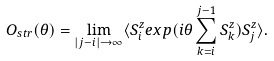<formula> <loc_0><loc_0><loc_500><loc_500>O _ { s t r } ( \theta ) = \lim _ { | j - i | \rightarrow \infty } \langle S ^ { z } _ { i } e x p ( i \theta \sum _ { k = i } ^ { j - 1 } S _ { k } ^ { z } ) S _ { j } ^ { z } \rangle .</formula> 